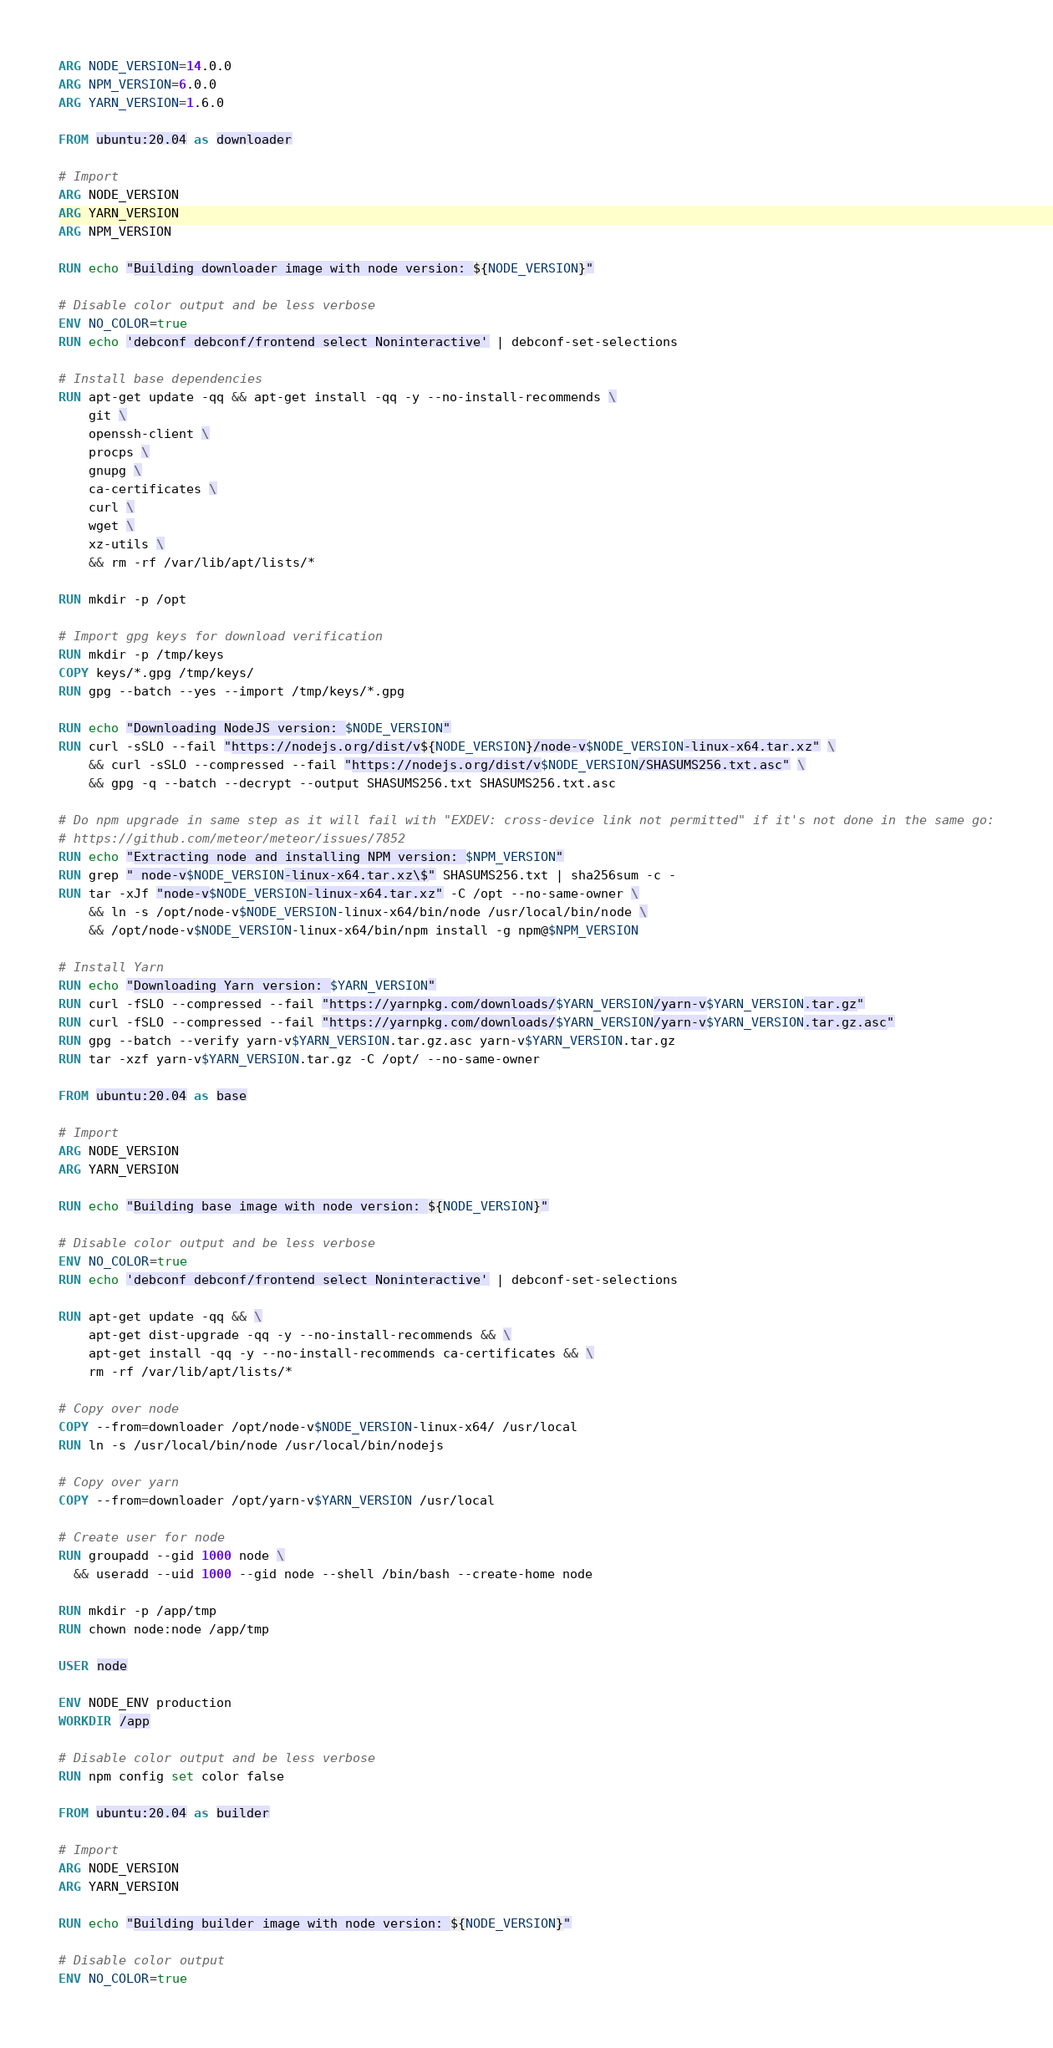Convert code to text. <code><loc_0><loc_0><loc_500><loc_500><_Dockerfile_>ARG NODE_VERSION=14.0.0
ARG NPM_VERSION=6.0.0
ARG YARN_VERSION=1.6.0

FROM ubuntu:20.04 as downloader

# Import
ARG NODE_VERSION
ARG YARN_VERSION
ARG NPM_VERSION

RUN echo "Building downloader image with node version: ${NODE_VERSION}"

# Disable color output and be less verbose
ENV NO_COLOR=true
RUN echo 'debconf debconf/frontend select Noninteractive' | debconf-set-selections

# Install base dependencies
RUN apt-get update -qq && apt-get install -qq -y --no-install-recommends \
	git \
	openssh-client \
	procps \
    gnupg \
    ca-certificates \
	curl \
	wget \
    xz-utils \
	&& rm -rf /var/lib/apt/lists/*

RUN mkdir -p /opt

# Import gpg keys for download verification
RUN mkdir -p /tmp/keys
COPY keys/*.gpg /tmp/keys/
RUN gpg --batch --yes --import /tmp/keys/*.gpg

RUN echo "Downloading NodeJS version: $NODE_VERSION"
RUN curl -sSLO --fail "https://nodejs.org/dist/v${NODE_VERSION}/node-v$NODE_VERSION-linux-x64.tar.xz" \
 	&& curl -sSLO --compressed --fail "https://nodejs.org/dist/v$NODE_VERSION/SHASUMS256.txt.asc" \
	&& gpg -q --batch --decrypt --output SHASUMS256.txt SHASUMS256.txt.asc

# Do npm upgrade in same step as it will fail with "EXDEV: cross-device link not permitted" if it's not done in the same go:
# https://github.com/meteor/meteor/issues/7852
RUN echo "Extracting node and installing NPM version: $NPM_VERSION"
RUN grep " node-v$NODE_VERSION-linux-x64.tar.xz\$" SHASUMS256.txt | sha256sum -c -
RUN tar -xJf "node-v$NODE_VERSION-linux-x64.tar.xz" -C /opt --no-same-owner \
	&& ln -s /opt/node-v$NODE_VERSION-linux-x64/bin/node /usr/local/bin/node \
	&& /opt/node-v$NODE_VERSION-linux-x64/bin/npm install -g npm@$NPM_VERSION

# Install Yarn
RUN echo "Downloading Yarn version: $YARN_VERSION"
RUN curl -fSLO --compressed --fail "https://yarnpkg.com/downloads/$YARN_VERSION/yarn-v$YARN_VERSION.tar.gz"
RUN curl -fSLO --compressed --fail "https://yarnpkg.com/downloads/$YARN_VERSION/yarn-v$YARN_VERSION.tar.gz.asc"
RUN gpg --batch --verify yarn-v$YARN_VERSION.tar.gz.asc yarn-v$YARN_VERSION.tar.gz
RUN tar -xzf yarn-v$YARN_VERSION.tar.gz -C /opt/ --no-same-owner

FROM ubuntu:20.04 as base

# Import
ARG NODE_VERSION
ARG YARN_VERSION

RUN echo "Building base image with node version: ${NODE_VERSION}"

# Disable color output and be less verbose
ENV NO_COLOR=true
RUN echo 'debconf debconf/frontend select Noninteractive' | debconf-set-selections

RUN apt-get update -qq && \
	apt-get dist-upgrade -qq -y --no-install-recommends && \
	apt-get install -qq -y --no-install-recommends ca-certificates && \
	rm -rf /var/lib/apt/lists/*

# Copy over node
COPY --from=downloader /opt/node-v$NODE_VERSION-linux-x64/ /usr/local
RUN ln -s /usr/local/bin/node /usr/local/bin/nodejs

# Copy over yarn
COPY --from=downloader /opt/yarn-v$YARN_VERSION /usr/local

# Create user for node
RUN groupadd --gid 1000 node \
  && useradd --uid 1000 --gid node --shell /bin/bash --create-home node

RUN mkdir -p /app/tmp
RUN chown node:node /app/tmp

USER node

ENV NODE_ENV production
WORKDIR /app

# Disable color output and be less verbose
RUN npm config set color false

FROM ubuntu:20.04 as builder

# Import
ARG NODE_VERSION
ARG YARN_VERSION

RUN echo "Building builder image with node version: ${NODE_VERSION}"

# Disable color output 
ENV NO_COLOR=true</code> 